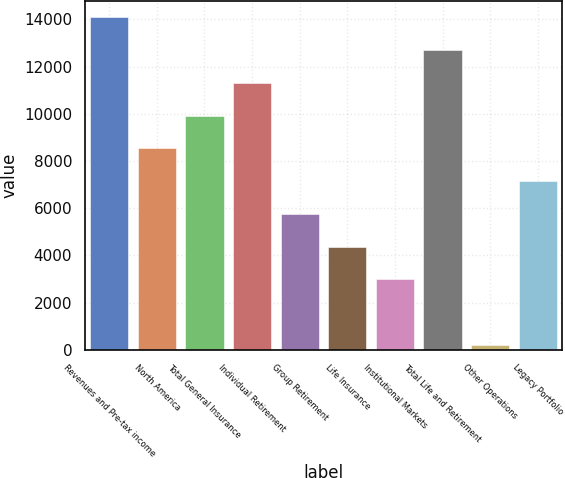Convert chart. <chart><loc_0><loc_0><loc_500><loc_500><bar_chart><fcel>Revenues and Pre-tax income<fcel>North America<fcel>Total General Insurance<fcel>Individual Retirement<fcel>Group Retirement<fcel>Life Insurance<fcel>Institutional Markets<fcel>Total Life and Retirement<fcel>Other Operations<fcel>Legacy Portfolio<nl><fcel>14096<fcel>8536<fcel>9926<fcel>11316<fcel>5756<fcel>4366<fcel>2976<fcel>12706<fcel>196<fcel>7146<nl></chart> 